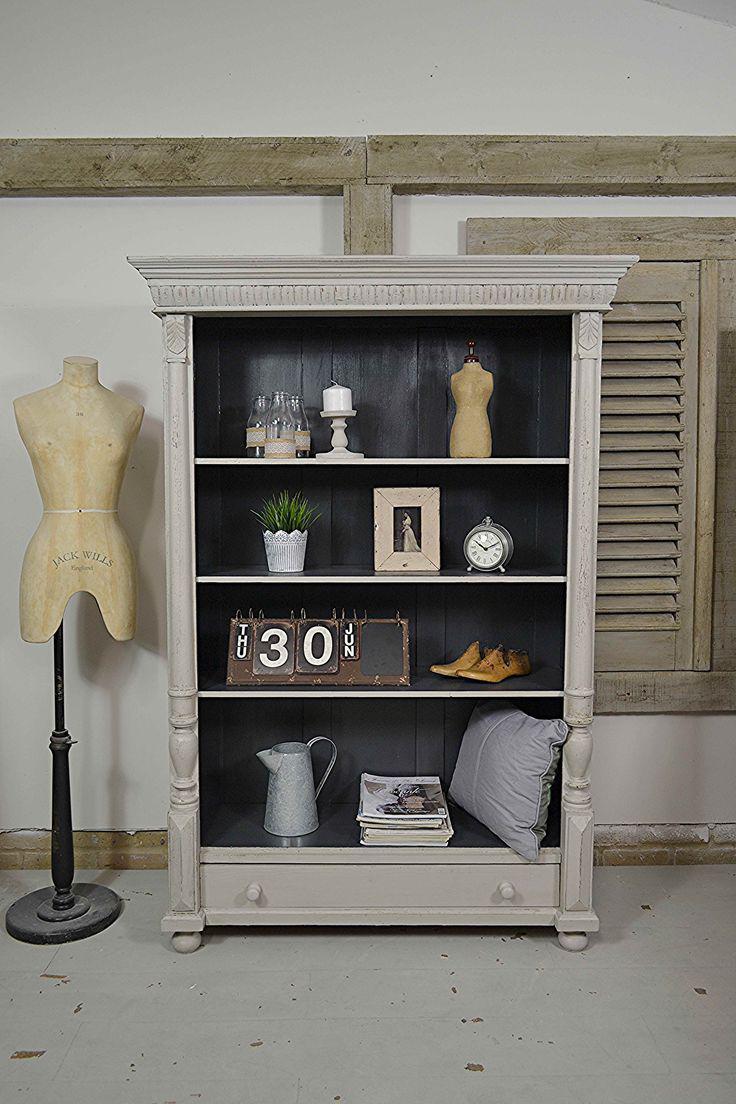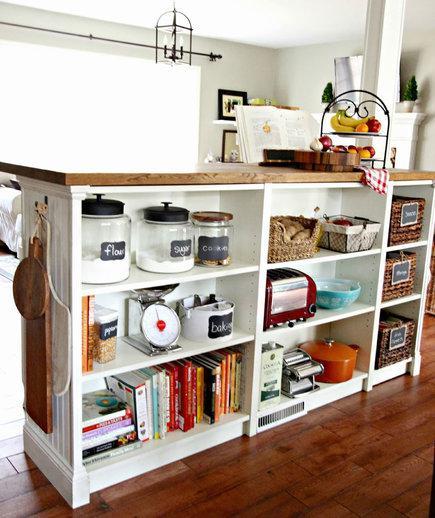The first image is the image on the left, the second image is the image on the right. Assess this claim about the two images: "Two shelf units, one on short legs and one flush with the floor, are different widths and have a different number of shelves.". Correct or not? Answer yes or no. Yes. The first image is the image on the left, the second image is the image on the right. Assess this claim about the two images: "One storage unit contains some blue bins with labels on the front, and the other holds several fiber-type baskets.". Correct or not? Answer yes or no. No. 